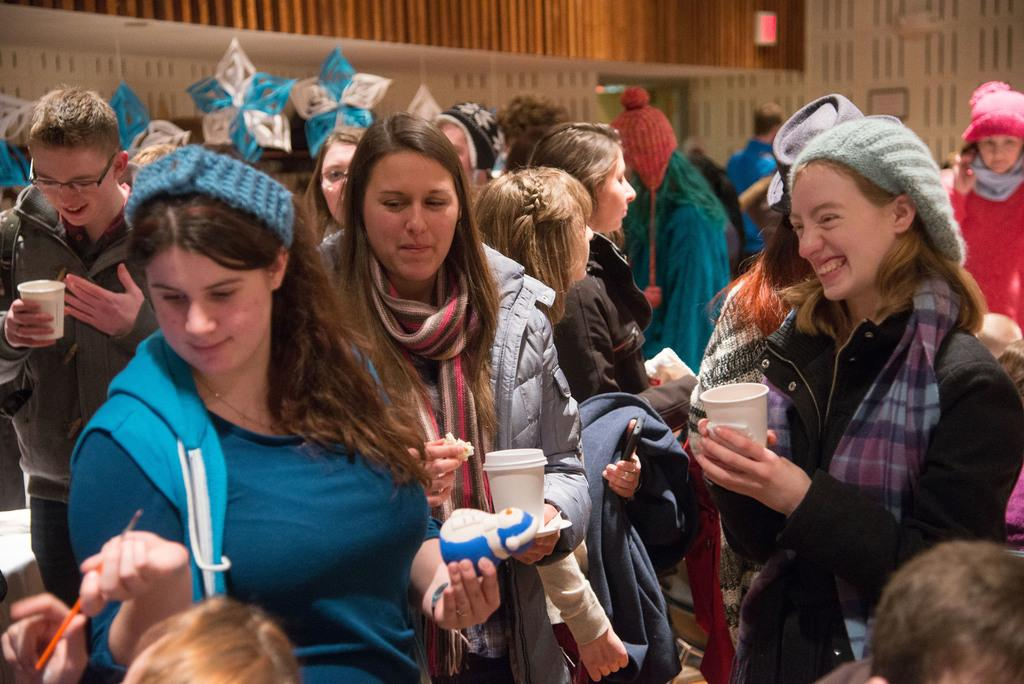What is happening in the image involving a group of people? There is a group of people in the image, and they are standing and holding objects. What can be seen in the image besides the people? There are decorative items in the image. What is visible in the background of the image? There is a wall in the background of the image. What type of credit is being offered to the people in the image? There is no mention of credit or any financial transaction in the image; it simply shows a group of people standing and holding objects. 